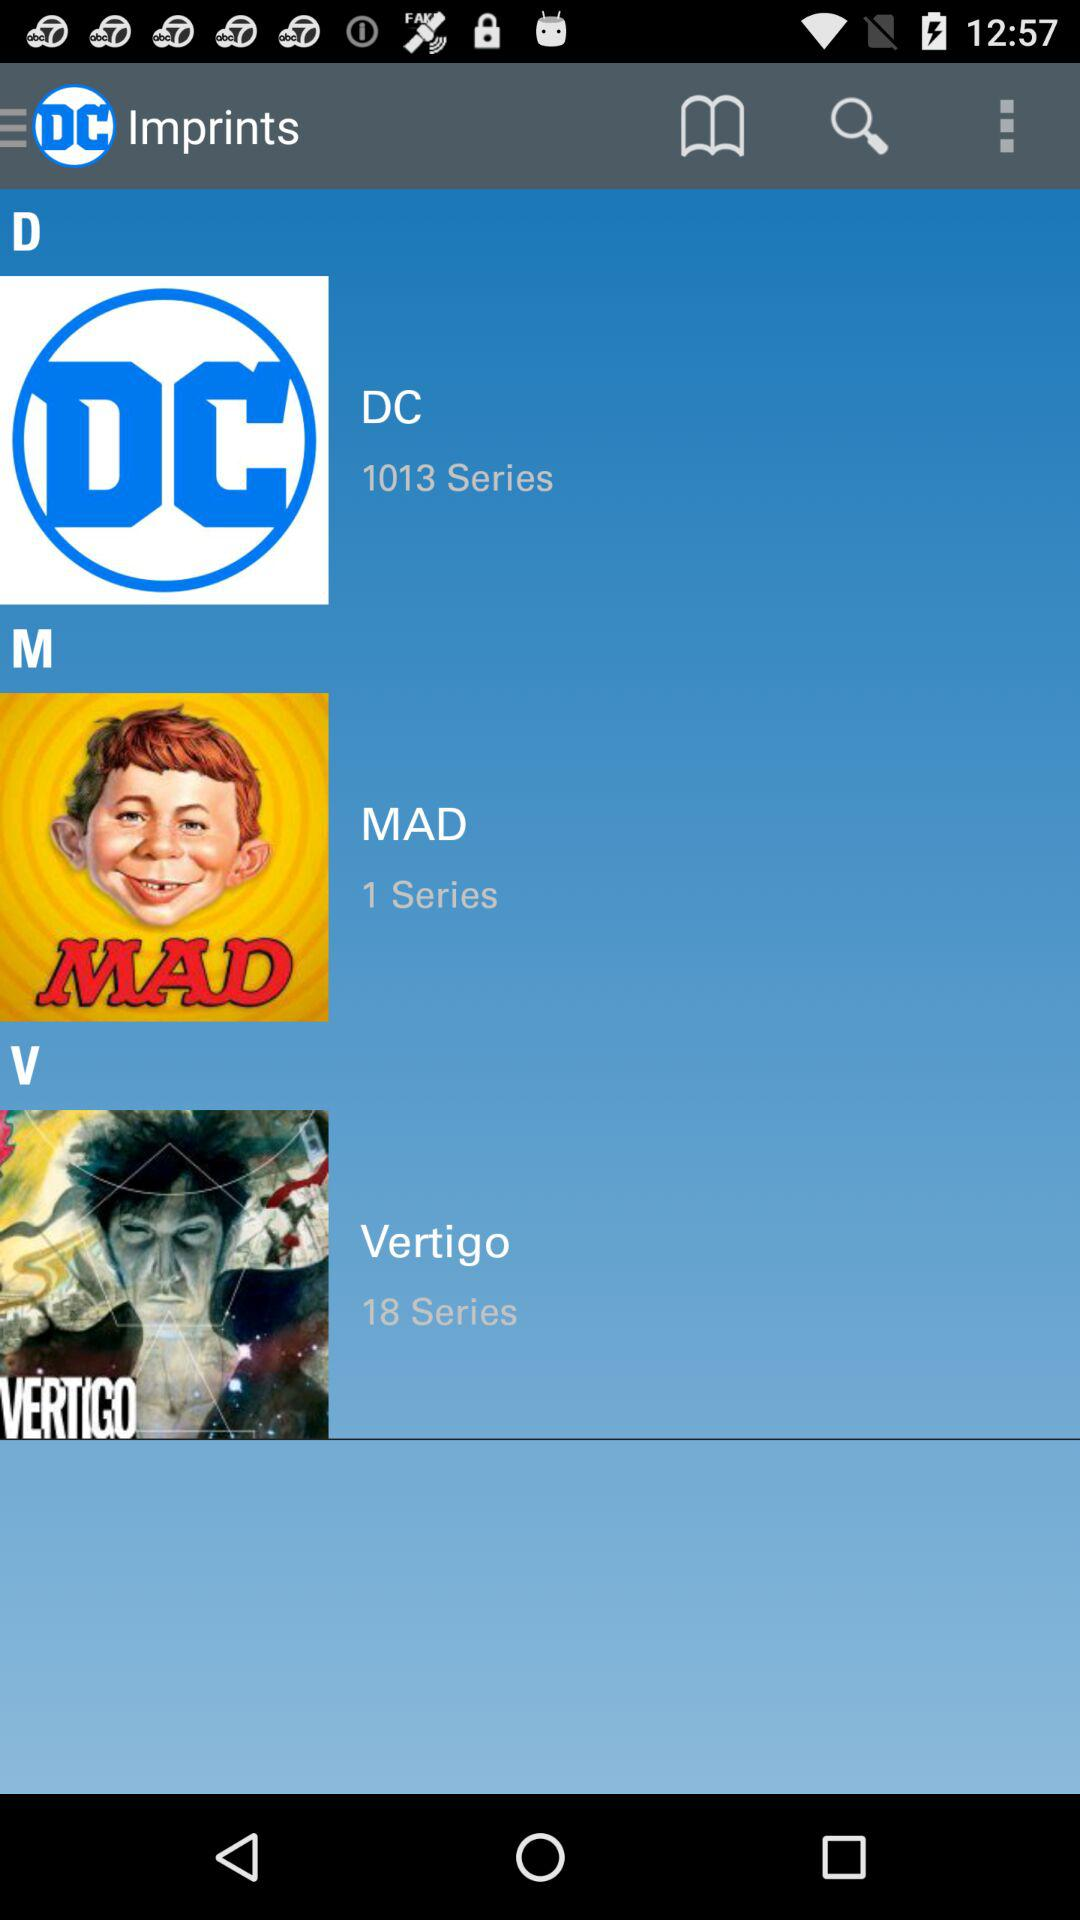How many series are there in the Vertigo imprint?
Answer the question using a single word or phrase. 18 